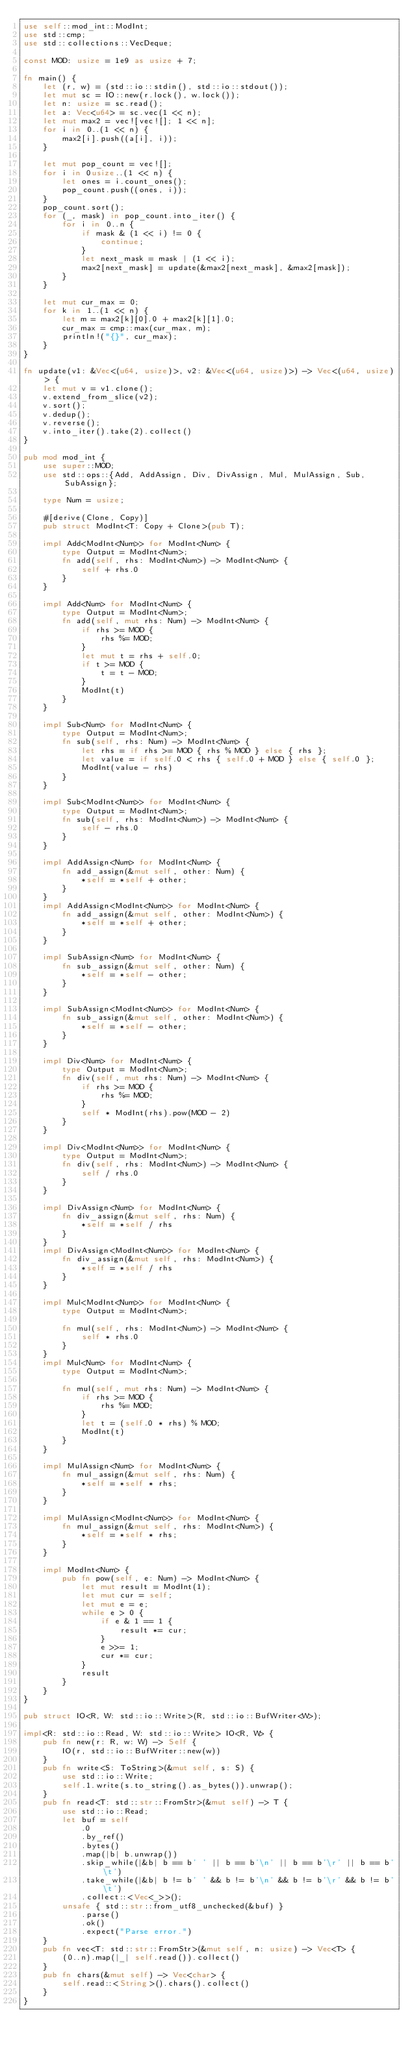Convert code to text. <code><loc_0><loc_0><loc_500><loc_500><_Rust_>use self::mod_int::ModInt;
use std::cmp;
use std::collections::VecDeque;

const MOD: usize = 1e9 as usize + 7;

fn main() {
    let (r, w) = (std::io::stdin(), std::io::stdout());
    let mut sc = IO::new(r.lock(), w.lock());
    let n: usize = sc.read();
    let a: Vec<u64> = sc.vec(1 << n);
    let mut max2 = vec![vec![]; 1 << n];
    for i in 0..(1 << n) {
        max2[i].push((a[i], i));
    }

    let mut pop_count = vec![];
    for i in 0usize..(1 << n) {
        let ones = i.count_ones();
        pop_count.push((ones, i));
    }
    pop_count.sort();
    for (_, mask) in pop_count.into_iter() {
        for i in 0..n {
            if mask & (1 << i) != 0 {
                continue;
            }
            let next_mask = mask | (1 << i);
            max2[next_mask] = update(&max2[next_mask], &max2[mask]);
        }
    }

    let mut cur_max = 0;
    for k in 1..(1 << n) {
        let m = max2[k][0].0 + max2[k][1].0;
        cur_max = cmp::max(cur_max, m);
        println!("{}", cur_max);
    }
}

fn update(v1: &Vec<(u64, usize)>, v2: &Vec<(u64, usize)>) -> Vec<(u64, usize)> {
    let mut v = v1.clone();
    v.extend_from_slice(v2);
    v.sort();
    v.dedup();
    v.reverse();
    v.into_iter().take(2).collect()
}

pub mod mod_int {
    use super::MOD;
    use std::ops::{Add, AddAssign, Div, DivAssign, Mul, MulAssign, Sub, SubAssign};

    type Num = usize;

    #[derive(Clone, Copy)]
    pub struct ModInt<T: Copy + Clone>(pub T);

    impl Add<ModInt<Num>> for ModInt<Num> {
        type Output = ModInt<Num>;
        fn add(self, rhs: ModInt<Num>) -> ModInt<Num> {
            self + rhs.0
        }
    }

    impl Add<Num> for ModInt<Num> {
        type Output = ModInt<Num>;
        fn add(self, mut rhs: Num) -> ModInt<Num> {
            if rhs >= MOD {
                rhs %= MOD;
            }
            let mut t = rhs + self.0;
            if t >= MOD {
                t = t - MOD;
            }
            ModInt(t)
        }
    }

    impl Sub<Num> for ModInt<Num> {
        type Output = ModInt<Num>;
        fn sub(self, rhs: Num) -> ModInt<Num> {
            let rhs = if rhs >= MOD { rhs % MOD } else { rhs };
            let value = if self.0 < rhs { self.0 + MOD } else { self.0 };
            ModInt(value - rhs)
        }
    }

    impl Sub<ModInt<Num>> for ModInt<Num> {
        type Output = ModInt<Num>;
        fn sub(self, rhs: ModInt<Num>) -> ModInt<Num> {
            self - rhs.0
        }
    }

    impl AddAssign<Num> for ModInt<Num> {
        fn add_assign(&mut self, other: Num) {
            *self = *self + other;
        }
    }
    impl AddAssign<ModInt<Num>> for ModInt<Num> {
        fn add_assign(&mut self, other: ModInt<Num>) {
            *self = *self + other;
        }
    }

    impl SubAssign<Num> for ModInt<Num> {
        fn sub_assign(&mut self, other: Num) {
            *self = *self - other;
        }
    }

    impl SubAssign<ModInt<Num>> for ModInt<Num> {
        fn sub_assign(&mut self, other: ModInt<Num>) {
            *self = *self - other;
        }
    }

    impl Div<Num> for ModInt<Num> {
        type Output = ModInt<Num>;
        fn div(self, mut rhs: Num) -> ModInt<Num> {
            if rhs >= MOD {
                rhs %= MOD;
            }
            self * ModInt(rhs).pow(MOD - 2)
        }
    }

    impl Div<ModInt<Num>> for ModInt<Num> {
        type Output = ModInt<Num>;
        fn div(self, rhs: ModInt<Num>) -> ModInt<Num> {
            self / rhs.0
        }
    }

    impl DivAssign<Num> for ModInt<Num> {
        fn div_assign(&mut self, rhs: Num) {
            *self = *self / rhs
        }
    }
    impl DivAssign<ModInt<Num>> for ModInt<Num> {
        fn div_assign(&mut self, rhs: ModInt<Num>) {
            *self = *self / rhs
        }
    }

    impl Mul<ModInt<Num>> for ModInt<Num> {
        type Output = ModInt<Num>;

        fn mul(self, rhs: ModInt<Num>) -> ModInt<Num> {
            self * rhs.0
        }
    }
    impl Mul<Num> for ModInt<Num> {
        type Output = ModInt<Num>;

        fn mul(self, mut rhs: Num) -> ModInt<Num> {
            if rhs >= MOD {
                rhs %= MOD;
            }
            let t = (self.0 * rhs) % MOD;
            ModInt(t)
        }
    }

    impl MulAssign<Num> for ModInt<Num> {
        fn mul_assign(&mut self, rhs: Num) {
            *self = *self * rhs;
        }
    }

    impl MulAssign<ModInt<Num>> for ModInt<Num> {
        fn mul_assign(&mut self, rhs: ModInt<Num>) {
            *self = *self * rhs;
        }
    }

    impl ModInt<Num> {
        pub fn pow(self, e: Num) -> ModInt<Num> {
            let mut result = ModInt(1);
            let mut cur = self;
            let mut e = e;
            while e > 0 {
                if e & 1 == 1 {
                    result *= cur;
                }
                e >>= 1;
                cur *= cur;
            }
            result
        }
    }
}

pub struct IO<R, W: std::io::Write>(R, std::io::BufWriter<W>);

impl<R: std::io::Read, W: std::io::Write> IO<R, W> {
    pub fn new(r: R, w: W) -> Self {
        IO(r, std::io::BufWriter::new(w))
    }
    pub fn write<S: ToString>(&mut self, s: S) {
        use std::io::Write;
        self.1.write(s.to_string().as_bytes()).unwrap();
    }
    pub fn read<T: std::str::FromStr>(&mut self) -> T {
        use std::io::Read;
        let buf = self
            .0
            .by_ref()
            .bytes()
            .map(|b| b.unwrap())
            .skip_while(|&b| b == b' ' || b == b'\n' || b == b'\r' || b == b'\t')
            .take_while(|&b| b != b' ' && b != b'\n' && b != b'\r' && b != b'\t')
            .collect::<Vec<_>>();
        unsafe { std::str::from_utf8_unchecked(&buf) }
            .parse()
            .ok()
            .expect("Parse error.")
    }
    pub fn vec<T: std::str::FromStr>(&mut self, n: usize) -> Vec<T> {
        (0..n).map(|_| self.read()).collect()
    }
    pub fn chars(&mut self) -> Vec<char> {
        self.read::<String>().chars().collect()
    }
}
</code> 